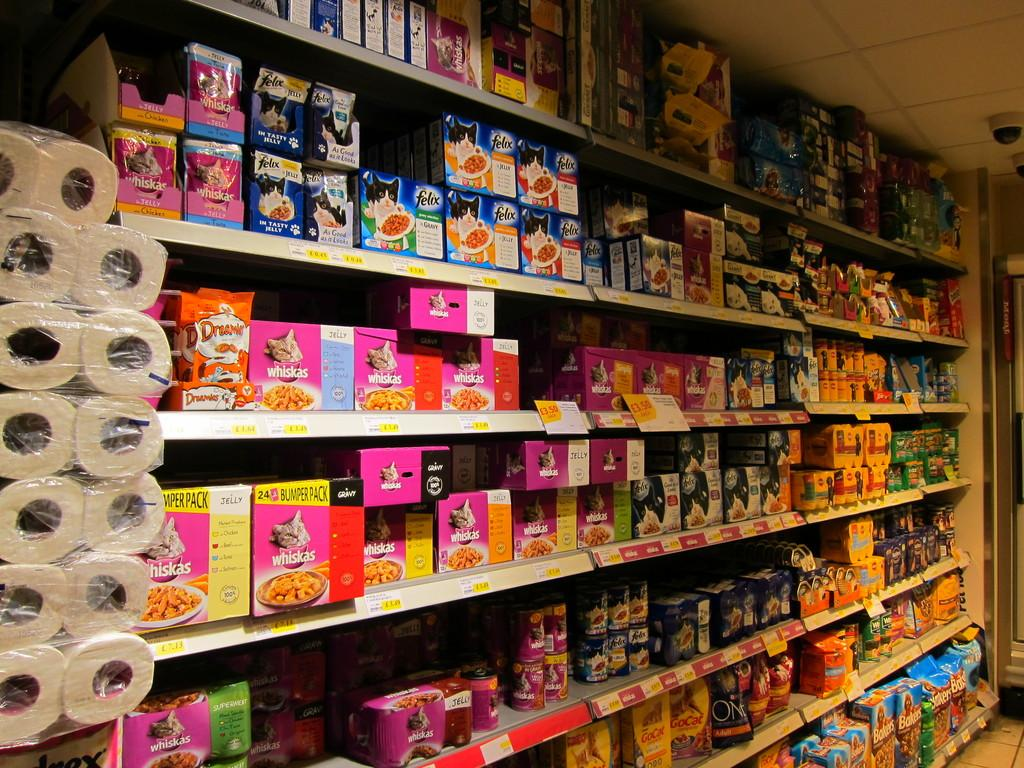<image>
Share a concise interpretation of the image provided. Boxes of Whiskas cat food are lined up on a store shelf. 